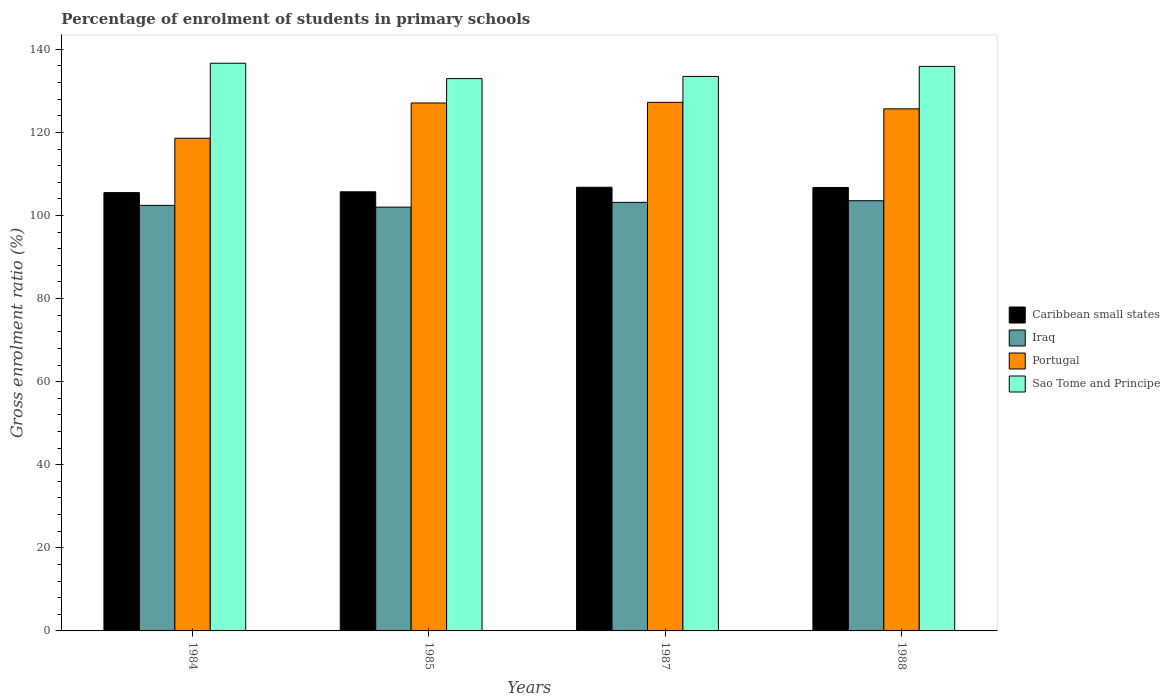How many different coloured bars are there?
Provide a succinct answer. 4. How many groups of bars are there?
Offer a terse response. 4. Are the number of bars per tick equal to the number of legend labels?
Give a very brief answer. Yes. Are the number of bars on each tick of the X-axis equal?
Offer a terse response. Yes. How many bars are there on the 2nd tick from the left?
Provide a succinct answer. 4. What is the percentage of students enrolled in primary schools in Portugal in 1984?
Provide a short and direct response. 118.59. Across all years, what is the maximum percentage of students enrolled in primary schools in Portugal?
Provide a short and direct response. 127.24. Across all years, what is the minimum percentage of students enrolled in primary schools in Caribbean small states?
Ensure brevity in your answer.  105.51. What is the total percentage of students enrolled in primary schools in Portugal in the graph?
Offer a very short reply. 498.58. What is the difference between the percentage of students enrolled in primary schools in Sao Tome and Principe in 1987 and that in 1988?
Give a very brief answer. -2.41. What is the difference between the percentage of students enrolled in primary schools in Caribbean small states in 1985 and the percentage of students enrolled in primary schools in Portugal in 1984?
Your response must be concise. -12.89. What is the average percentage of students enrolled in primary schools in Sao Tome and Principe per year?
Your response must be concise. 134.74. In the year 1985, what is the difference between the percentage of students enrolled in primary schools in Iraq and percentage of students enrolled in primary schools in Caribbean small states?
Your answer should be compact. -3.69. What is the ratio of the percentage of students enrolled in primary schools in Portugal in 1984 to that in 1988?
Provide a succinct answer. 0.94. Is the difference between the percentage of students enrolled in primary schools in Iraq in 1985 and 1987 greater than the difference between the percentage of students enrolled in primary schools in Caribbean small states in 1985 and 1987?
Give a very brief answer. No. What is the difference between the highest and the second highest percentage of students enrolled in primary schools in Portugal?
Ensure brevity in your answer.  0.16. What is the difference between the highest and the lowest percentage of students enrolled in primary schools in Caribbean small states?
Your response must be concise. 1.29. In how many years, is the percentage of students enrolled in primary schools in Sao Tome and Principe greater than the average percentage of students enrolled in primary schools in Sao Tome and Principe taken over all years?
Your answer should be very brief. 2. Is the sum of the percentage of students enrolled in primary schools in Iraq in 1984 and 1985 greater than the maximum percentage of students enrolled in primary schools in Sao Tome and Principe across all years?
Offer a terse response. Yes. What does the 4th bar from the left in 1984 represents?
Provide a short and direct response. Sao Tome and Principe. What does the 3rd bar from the right in 1984 represents?
Provide a short and direct response. Iraq. Is it the case that in every year, the sum of the percentage of students enrolled in primary schools in Sao Tome and Principe and percentage of students enrolled in primary schools in Portugal is greater than the percentage of students enrolled in primary schools in Iraq?
Give a very brief answer. Yes. How many years are there in the graph?
Your response must be concise. 4. What is the difference between two consecutive major ticks on the Y-axis?
Provide a short and direct response. 20. Does the graph contain grids?
Provide a succinct answer. No. Where does the legend appear in the graph?
Ensure brevity in your answer.  Center right. What is the title of the graph?
Give a very brief answer. Percentage of enrolment of students in primary schools. What is the label or title of the Y-axis?
Give a very brief answer. Gross enrolment ratio (%). What is the Gross enrolment ratio (%) in Caribbean small states in 1984?
Your response must be concise. 105.51. What is the Gross enrolment ratio (%) in Iraq in 1984?
Your answer should be very brief. 102.44. What is the Gross enrolment ratio (%) in Portugal in 1984?
Your response must be concise. 118.59. What is the Gross enrolment ratio (%) in Sao Tome and Principe in 1984?
Your answer should be very brief. 136.64. What is the Gross enrolment ratio (%) of Caribbean small states in 1985?
Offer a very short reply. 105.7. What is the Gross enrolment ratio (%) of Iraq in 1985?
Your answer should be very brief. 102.01. What is the Gross enrolment ratio (%) of Portugal in 1985?
Provide a succinct answer. 127.08. What is the Gross enrolment ratio (%) in Sao Tome and Principe in 1985?
Your answer should be compact. 132.95. What is the Gross enrolment ratio (%) of Caribbean small states in 1987?
Provide a succinct answer. 106.8. What is the Gross enrolment ratio (%) in Iraq in 1987?
Offer a terse response. 103.16. What is the Gross enrolment ratio (%) of Portugal in 1987?
Provide a short and direct response. 127.24. What is the Gross enrolment ratio (%) in Sao Tome and Principe in 1987?
Keep it short and to the point. 133.47. What is the Gross enrolment ratio (%) in Caribbean small states in 1988?
Provide a succinct answer. 106.75. What is the Gross enrolment ratio (%) in Iraq in 1988?
Make the answer very short. 103.56. What is the Gross enrolment ratio (%) in Portugal in 1988?
Offer a terse response. 125.67. What is the Gross enrolment ratio (%) of Sao Tome and Principe in 1988?
Your answer should be very brief. 135.89. Across all years, what is the maximum Gross enrolment ratio (%) of Caribbean small states?
Provide a short and direct response. 106.8. Across all years, what is the maximum Gross enrolment ratio (%) in Iraq?
Ensure brevity in your answer.  103.56. Across all years, what is the maximum Gross enrolment ratio (%) of Portugal?
Offer a terse response. 127.24. Across all years, what is the maximum Gross enrolment ratio (%) of Sao Tome and Principe?
Your answer should be compact. 136.64. Across all years, what is the minimum Gross enrolment ratio (%) in Caribbean small states?
Provide a short and direct response. 105.51. Across all years, what is the minimum Gross enrolment ratio (%) in Iraq?
Provide a succinct answer. 102.01. Across all years, what is the minimum Gross enrolment ratio (%) in Portugal?
Your answer should be compact. 118.59. Across all years, what is the minimum Gross enrolment ratio (%) of Sao Tome and Principe?
Provide a succinct answer. 132.95. What is the total Gross enrolment ratio (%) in Caribbean small states in the graph?
Your answer should be compact. 424.75. What is the total Gross enrolment ratio (%) in Iraq in the graph?
Offer a terse response. 411.16. What is the total Gross enrolment ratio (%) of Portugal in the graph?
Your answer should be very brief. 498.58. What is the total Gross enrolment ratio (%) of Sao Tome and Principe in the graph?
Provide a succinct answer. 538.96. What is the difference between the Gross enrolment ratio (%) in Caribbean small states in 1984 and that in 1985?
Offer a very short reply. -0.2. What is the difference between the Gross enrolment ratio (%) in Iraq in 1984 and that in 1985?
Give a very brief answer. 0.43. What is the difference between the Gross enrolment ratio (%) in Portugal in 1984 and that in 1985?
Keep it short and to the point. -8.49. What is the difference between the Gross enrolment ratio (%) of Sao Tome and Principe in 1984 and that in 1985?
Offer a terse response. 3.69. What is the difference between the Gross enrolment ratio (%) of Caribbean small states in 1984 and that in 1987?
Make the answer very short. -1.29. What is the difference between the Gross enrolment ratio (%) of Iraq in 1984 and that in 1987?
Offer a terse response. -0.72. What is the difference between the Gross enrolment ratio (%) in Portugal in 1984 and that in 1987?
Your response must be concise. -8.65. What is the difference between the Gross enrolment ratio (%) of Sao Tome and Principe in 1984 and that in 1987?
Your response must be concise. 3.17. What is the difference between the Gross enrolment ratio (%) of Caribbean small states in 1984 and that in 1988?
Provide a succinct answer. -1.24. What is the difference between the Gross enrolment ratio (%) in Iraq in 1984 and that in 1988?
Offer a terse response. -1.12. What is the difference between the Gross enrolment ratio (%) of Portugal in 1984 and that in 1988?
Your response must be concise. -7.08. What is the difference between the Gross enrolment ratio (%) of Sao Tome and Principe in 1984 and that in 1988?
Give a very brief answer. 0.76. What is the difference between the Gross enrolment ratio (%) of Caribbean small states in 1985 and that in 1987?
Your response must be concise. -1.1. What is the difference between the Gross enrolment ratio (%) in Iraq in 1985 and that in 1987?
Make the answer very short. -1.15. What is the difference between the Gross enrolment ratio (%) in Portugal in 1985 and that in 1987?
Give a very brief answer. -0.16. What is the difference between the Gross enrolment ratio (%) in Sao Tome and Principe in 1985 and that in 1987?
Offer a terse response. -0.52. What is the difference between the Gross enrolment ratio (%) in Caribbean small states in 1985 and that in 1988?
Keep it short and to the point. -1.05. What is the difference between the Gross enrolment ratio (%) of Iraq in 1985 and that in 1988?
Ensure brevity in your answer.  -1.55. What is the difference between the Gross enrolment ratio (%) in Portugal in 1985 and that in 1988?
Your answer should be very brief. 1.41. What is the difference between the Gross enrolment ratio (%) of Sao Tome and Principe in 1985 and that in 1988?
Your answer should be very brief. -2.94. What is the difference between the Gross enrolment ratio (%) in Caribbean small states in 1987 and that in 1988?
Offer a terse response. 0.05. What is the difference between the Gross enrolment ratio (%) in Iraq in 1987 and that in 1988?
Provide a short and direct response. -0.4. What is the difference between the Gross enrolment ratio (%) in Portugal in 1987 and that in 1988?
Offer a terse response. 1.57. What is the difference between the Gross enrolment ratio (%) in Sao Tome and Principe in 1987 and that in 1988?
Offer a terse response. -2.41. What is the difference between the Gross enrolment ratio (%) of Caribbean small states in 1984 and the Gross enrolment ratio (%) of Iraq in 1985?
Provide a short and direct response. 3.5. What is the difference between the Gross enrolment ratio (%) in Caribbean small states in 1984 and the Gross enrolment ratio (%) in Portugal in 1985?
Ensure brevity in your answer.  -21.57. What is the difference between the Gross enrolment ratio (%) in Caribbean small states in 1984 and the Gross enrolment ratio (%) in Sao Tome and Principe in 1985?
Ensure brevity in your answer.  -27.45. What is the difference between the Gross enrolment ratio (%) of Iraq in 1984 and the Gross enrolment ratio (%) of Portugal in 1985?
Provide a succinct answer. -24.64. What is the difference between the Gross enrolment ratio (%) in Iraq in 1984 and the Gross enrolment ratio (%) in Sao Tome and Principe in 1985?
Provide a succinct answer. -30.52. What is the difference between the Gross enrolment ratio (%) of Portugal in 1984 and the Gross enrolment ratio (%) of Sao Tome and Principe in 1985?
Offer a terse response. -14.36. What is the difference between the Gross enrolment ratio (%) in Caribbean small states in 1984 and the Gross enrolment ratio (%) in Iraq in 1987?
Give a very brief answer. 2.35. What is the difference between the Gross enrolment ratio (%) in Caribbean small states in 1984 and the Gross enrolment ratio (%) in Portugal in 1987?
Offer a terse response. -21.73. What is the difference between the Gross enrolment ratio (%) in Caribbean small states in 1984 and the Gross enrolment ratio (%) in Sao Tome and Principe in 1987?
Make the answer very short. -27.97. What is the difference between the Gross enrolment ratio (%) in Iraq in 1984 and the Gross enrolment ratio (%) in Portugal in 1987?
Provide a succinct answer. -24.8. What is the difference between the Gross enrolment ratio (%) in Iraq in 1984 and the Gross enrolment ratio (%) in Sao Tome and Principe in 1987?
Your answer should be compact. -31.04. What is the difference between the Gross enrolment ratio (%) in Portugal in 1984 and the Gross enrolment ratio (%) in Sao Tome and Principe in 1987?
Ensure brevity in your answer.  -14.88. What is the difference between the Gross enrolment ratio (%) of Caribbean small states in 1984 and the Gross enrolment ratio (%) of Iraq in 1988?
Offer a terse response. 1.95. What is the difference between the Gross enrolment ratio (%) of Caribbean small states in 1984 and the Gross enrolment ratio (%) of Portugal in 1988?
Make the answer very short. -20.16. What is the difference between the Gross enrolment ratio (%) in Caribbean small states in 1984 and the Gross enrolment ratio (%) in Sao Tome and Principe in 1988?
Your response must be concise. -30.38. What is the difference between the Gross enrolment ratio (%) in Iraq in 1984 and the Gross enrolment ratio (%) in Portugal in 1988?
Make the answer very short. -23.23. What is the difference between the Gross enrolment ratio (%) in Iraq in 1984 and the Gross enrolment ratio (%) in Sao Tome and Principe in 1988?
Make the answer very short. -33.45. What is the difference between the Gross enrolment ratio (%) of Portugal in 1984 and the Gross enrolment ratio (%) of Sao Tome and Principe in 1988?
Your answer should be compact. -17.3. What is the difference between the Gross enrolment ratio (%) in Caribbean small states in 1985 and the Gross enrolment ratio (%) in Iraq in 1987?
Ensure brevity in your answer.  2.54. What is the difference between the Gross enrolment ratio (%) in Caribbean small states in 1985 and the Gross enrolment ratio (%) in Portugal in 1987?
Give a very brief answer. -21.54. What is the difference between the Gross enrolment ratio (%) in Caribbean small states in 1985 and the Gross enrolment ratio (%) in Sao Tome and Principe in 1987?
Provide a short and direct response. -27.77. What is the difference between the Gross enrolment ratio (%) of Iraq in 1985 and the Gross enrolment ratio (%) of Portugal in 1987?
Your answer should be compact. -25.23. What is the difference between the Gross enrolment ratio (%) in Iraq in 1985 and the Gross enrolment ratio (%) in Sao Tome and Principe in 1987?
Ensure brevity in your answer.  -31.47. What is the difference between the Gross enrolment ratio (%) of Portugal in 1985 and the Gross enrolment ratio (%) of Sao Tome and Principe in 1987?
Ensure brevity in your answer.  -6.4. What is the difference between the Gross enrolment ratio (%) in Caribbean small states in 1985 and the Gross enrolment ratio (%) in Iraq in 1988?
Offer a very short reply. 2.14. What is the difference between the Gross enrolment ratio (%) in Caribbean small states in 1985 and the Gross enrolment ratio (%) in Portugal in 1988?
Ensure brevity in your answer.  -19.97. What is the difference between the Gross enrolment ratio (%) of Caribbean small states in 1985 and the Gross enrolment ratio (%) of Sao Tome and Principe in 1988?
Provide a succinct answer. -30.19. What is the difference between the Gross enrolment ratio (%) in Iraq in 1985 and the Gross enrolment ratio (%) in Portugal in 1988?
Give a very brief answer. -23.66. What is the difference between the Gross enrolment ratio (%) in Iraq in 1985 and the Gross enrolment ratio (%) in Sao Tome and Principe in 1988?
Offer a very short reply. -33.88. What is the difference between the Gross enrolment ratio (%) of Portugal in 1985 and the Gross enrolment ratio (%) of Sao Tome and Principe in 1988?
Your response must be concise. -8.81. What is the difference between the Gross enrolment ratio (%) of Caribbean small states in 1987 and the Gross enrolment ratio (%) of Iraq in 1988?
Your answer should be compact. 3.24. What is the difference between the Gross enrolment ratio (%) in Caribbean small states in 1987 and the Gross enrolment ratio (%) in Portugal in 1988?
Your response must be concise. -18.87. What is the difference between the Gross enrolment ratio (%) of Caribbean small states in 1987 and the Gross enrolment ratio (%) of Sao Tome and Principe in 1988?
Offer a terse response. -29.09. What is the difference between the Gross enrolment ratio (%) of Iraq in 1987 and the Gross enrolment ratio (%) of Portugal in 1988?
Offer a terse response. -22.51. What is the difference between the Gross enrolment ratio (%) in Iraq in 1987 and the Gross enrolment ratio (%) in Sao Tome and Principe in 1988?
Give a very brief answer. -32.73. What is the difference between the Gross enrolment ratio (%) in Portugal in 1987 and the Gross enrolment ratio (%) in Sao Tome and Principe in 1988?
Make the answer very short. -8.65. What is the average Gross enrolment ratio (%) of Caribbean small states per year?
Ensure brevity in your answer.  106.19. What is the average Gross enrolment ratio (%) of Iraq per year?
Make the answer very short. 102.79. What is the average Gross enrolment ratio (%) in Portugal per year?
Give a very brief answer. 124.64. What is the average Gross enrolment ratio (%) of Sao Tome and Principe per year?
Your answer should be very brief. 134.74. In the year 1984, what is the difference between the Gross enrolment ratio (%) of Caribbean small states and Gross enrolment ratio (%) of Iraq?
Give a very brief answer. 3.07. In the year 1984, what is the difference between the Gross enrolment ratio (%) in Caribbean small states and Gross enrolment ratio (%) in Portugal?
Your response must be concise. -13.09. In the year 1984, what is the difference between the Gross enrolment ratio (%) in Caribbean small states and Gross enrolment ratio (%) in Sao Tome and Principe?
Ensure brevity in your answer.  -31.14. In the year 1984, what is the difference between the Gross enrolment ratio (%) of Iraq and Gross enrolment ratio (%) of Portugal?
Your answer should be compact. -16.15. In the year 1984, what is the difference between the Gross enrolment ratio (%) of Iraq and Gross enrolment ratio (%) of Sao Tome and Principe?
Your answer should be compact. -34.21. In the year 1984, what is the difference between the Gross enrolment ratio (%) in Portugal and Gross enrolment ratio (%) in Sao Tome and Principe?
Your answer should be very brief. -18.05. In the year 1985, what is the difference between the Gross enrolment ratio (%) in Caribbean small states and Gross enrolment ratio (%) in Iraq?
Your answer should be very brief. 3.69. In the year 1985, what is the difference between the Gross enrolment ratio (%) in Caribbean small states and Gross enrolment ratio (%) in Portugal?
Give a very brief answer. -21.38. In the year 1985, what is the difference between the Gross enrolment ratio (%) in Caribbean small states and Gross enrolment ratio (%) in Sao Tome and Principe?
Keep it short and to the point. -27.25. In the year 1985, what is the difference between the Gross enrolment ratio (%) of Iraq and Gross enrolment ratio (%) of Portugal?
Give a very brief answer. -25.07. In the year 1985, what is the difference between the Gross enrolment ratio (%) in Iraq and Gross enrolment ratio (%) in Sao Tome and Principe?
Provide a short and direct response. -30.94. In the year 1985, what is the difference between the Gross enrolment ratio (%) of Portugal and Gross enrolment ratio (%) of Sao Tome and Principe?
Your response must be concise. -5.87. In the year 1987, what is the difference between the Gross enrolment ratio (%) of Caribbean small states and Gross enrolment ratio (%) of Iraq?
Your answer should be compact. 3.64. In the year 1987, what is the difference between the Gross enrolment ratio (%) of Caribbean small states and Gross enrolment ratio (%) of Portugal?
Your answer should be compact. -20.44. In the year 1987, what is the difference between the Gross enrolment ratio (%) in Caribbean small states and Gross enrolment ratio (%) in Sao Tome and Principe?
Ensure brevity in your answer.  -26.68. In the year 1987, what is the difference between the Gross enrolment ratio (%) in Iraq and Gross enrolment ratio (%) in Portugal?
Make the answer very short. -24.08. In the year 1987, what is the difference between the Gross enrolment ratio (%) of Iraq and Gross enrolment ratio (%) of Sao Tome and Principe?
Your answer should be very brief. -30.32. In the year 1987, what is the difference between the Gross enrolment ratio (%) of Portugal and Gross enrolment ratio (%) of Sao Tome and Principe?
Your response must be concise. -6.24. In the year 1988, what is the difference between the Gross enrolment ratio (%) in Caribbean small states and Gross enrolment ratio (%) in Iraq?
Your answer should be very brief. 3.19. In the year 1988, what is the difference between the Gross enrolment ratio (%) in Caribbean small states and Gross enrolment ratio (%) in Portugal?
Keep it short and to the point. -18.92. In the year 1988, what is the difference between the Gross enrolment ratio (%) in Caribbean small states and Gross enrolment ratio (%) in Sao Tome and Principe?
Give a very brief answer. -29.14. In the year 1988, what is the difference between the Gross enrolment ratio (%) in Iraq and Gross enrolment ratio (%) in Portugal?
Make the answer very short. -22.11. In the year 1988, what is the difference between the Gross enrolment ratio (%) in Iraq and Gross enrolment ratio (%) in Sao Tome and Principe?
Your response must be concise. -32.33. In the year 1988, what is the difference between the Gross enrolment ratio (%) of Portugal and Gross enrolment ratio (%) of Sao Tome and Principe?
Your answer should be compact. -10.22. What is the ratio of the Gross enrolment ratio (%) of Caribbean small states in 1984 to that in 1985?
Make the answer very short. 1. What is the ratio of the Gross enrolment ratio (%) of Portugal in 1984 to that in 1985?
Ensure brevity in your answer.  0.93. What is the ratio of the Gross enrolment ratio (%) in Sao Tome and Principe in 1984 to that in 1985?
Offer a very short reply. 1.03. What is the ratio of the Gross enrolment ratio (%) in Caribbean small states in 1984 to that in 1987?
Offer a very short reply. 0.99. What is the ratio of the Gross enrolment ratio (%) in Portugal in 1984 to that in 1987?
Give a very brief answer. 0.93. What is the ratio of the Gross enrolment ratio (%) in Sao Tome and Principe in 1984 to that in 1987?
Offer a terse response. 1.02. What is the ratio of the Gross enrolment ratio (%) of Caribbean small states in 1984 to that in 1988?
Your answer should be compact. 0.99. What is the ratio of the Gross enrolment ratio (%) in Iraq in 1984 to that in 1988?
Provide a short and direct response. 0.99. What is the ratio of the Gross enrolment ratio (%) in Portugal in 1984 to that in 1988?
Offer a very short reply. 0.94. What is the ratio of the Gross enrolment ratio (%) in Sao Tome and Principe in 1984 to that in 1988?
Make the answer very short. 1.01. What is the ratio of the Gross enrolment ratio (%) of Caribbean small states in 1985 to that in 1987?
Offer a very short reply. 0.99. What is the ratio of the Gross enrolment ratio (%) in Iraq in 1985 to that in 1987?
Ensure brevity in your answer.  0.99. What is the ratio of the Gross enrolment ratio (%) of Portugal in 1985 to that in 1987?
Offer a terse response. 1. What is the ratio of the Gross enrolment ratio (%) in Caribbean small states in 1985 to that in 1988?
Make the answer very short. 0.99. What is the ratio of the Gross enrolment ratio (%) of Iraq in 1985 to that in 1988?
Ensure brevity in your answer.  0.99. What is the ratio of the Gross enrolment ratio (%) of Portugal in 1985 to that in 1988?
Keep it short and to the point. 1.01. What is the ratio of the Gross enrolment ratio (%) in Sao Tome and Principe in 1985 to that in 1988?
Make the answer very short. 0.98. What is the ratio of the Gross enrolment ratio (%) of Caribbean small states in 1987 to that in 1988?
Your response must be concise. 1. What is the ratio of the Gross enrolment ratio (%) of Portugal in 1987 to that in 1988?
Your answer should be compact. 1.01. What is the ratio of the Gross enrolment ratio (%) of Sao Tome and Principe in 1987 to that in 1988?
Make the answer very short. 0.98. What is the difference between the highest and the second highest Gross enrolment ratio (%) in Caribbean small states?
Ensure brevity in your answer.  0.05. What is the difference between the highest and the second highest Gross enrolment ratio (%) of Iraq?
Ensure brevity in your answer.  0.4. What is the difference between the highest and the second highest Gross enrolment ratio (%) in Portugal?
Offer a terse response. 0.16. What is the difference between the highest and the second highest Gross enrolment ratio (%) of Sao Tome and Principe?
Ensure brevity in your answer.  0.76. What is the difference between the highest and the lowest Gross enrolment ratio (%) in Caribbean small states?
Keep it short and to the point. 1.29. What is the difference between the highest and the lowest Gross enrolment ratio (%) of Iraq?
Keep it short and to the point. 1.55. What is the difference between the highest and the lowest Gross enrolment ratio (%) in Portugal?
Your answer should be compact. 8.65. What is the difference between the highest and the lowest Gross enrolment ratio (%) of Sao Tome and Principe?
Provide a short and direct response. 3.69. 